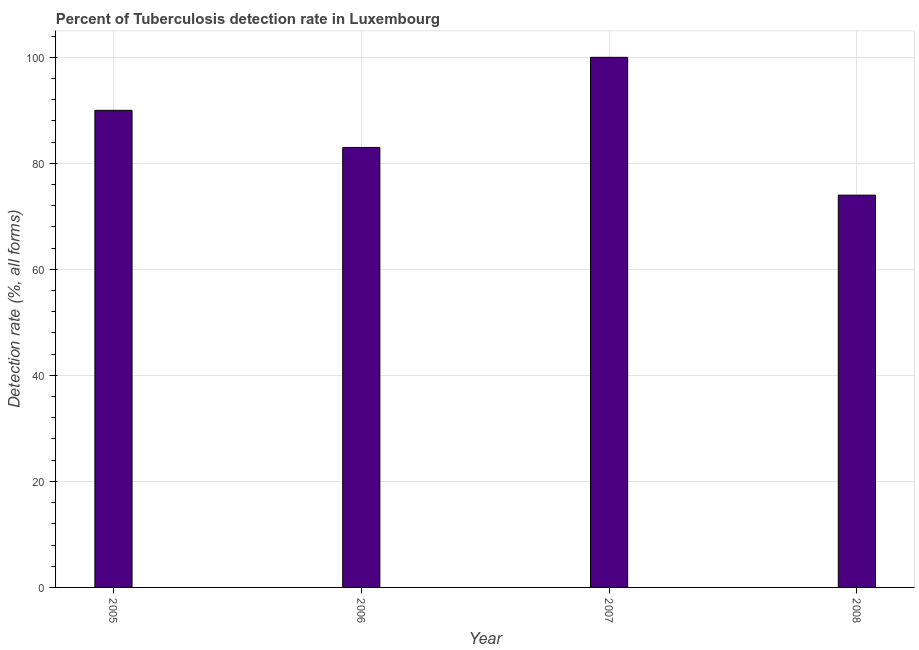Does the graph contain any zero values?
Provide a short and direct response. No. What is the title of the graph?
Provide a succinct answer. Percent of Tuberculosis detection rate in Luxembourg. What is the label or title of the X-axis?
Ensure brevity in your answer.  Year. What is the label or title of the Y-axis?
Your answer should be very brief. Detection rate (%, all forms). What is the detection rate of tuberculosis in 2005?
Your response must be concise. 90. Across all years, what is the minimum detection rate of tuberculosis?
Your response must be concise. 74. What is the sum of the detection rate of tuberculosis?
Offer a terse response. 347. What is the average detection rate of tuberculosis per year?
Give a very brief answer. 86. What is the median detection rate of tuberculosis?
Your answer should be very brief. 86.5. What is the ratio of the detection rate of tuberculosis in 2006 to that in 2008?
Ensure brevity in your answer.  1.12. Is the detection rate of tuberculosis in 2005 less than that in 2006?
Provide a succinct answer. No. Is the difference between the detection rate of tuberculosis in 2005 and 2006 greater than the difference between any two years?
Your answer should be compact. No. What is the difference between the highest and the lowest detection rate of tuberculosis?
Ensure brevity in your answer.  26. Are all the bars in the graph horizontal?
Your answer should be compact. No. What is the difference between two consecutive major ticks on the Y-axis?
Keep it short and to the point. 20. Are the values on the major ticks of Y-axis written in scientific E-notation?
Provide a short and direct response. No. What is the Detection rate (%, all forms) of 2007?
Your answer should be very brief. 100. What is the difference between the Detection rate (%, all forms) in 2005 and 2007?
Your answer should be very brief. -10. What is the ratio of the Detection rate (%, all forms) in 2005 to that in 2006?
Your answer should be compact. 1.08. What is the ratio of the Detection rate (%, all forms) in 2005 to that in 2007?
Your response must be concise. 0.9. What is the ratio of the Detection rate (%, all forms) in 2005 to that in 2008?
Offer a very short reply. 1.22. What is the ratio of the Detection rate (%, all forms) in 2006 to that in 2007?
Your answer should be compact. 0.83. What is the ratio of the Detection rate (%, all forms) in 2006 to that in 2008?
Provide a succinct answer. 1.12. What is the ratio of the Detection rate (%, all forms) in 2007 to that in 2008?
Your answer should be compact. 1.35. 